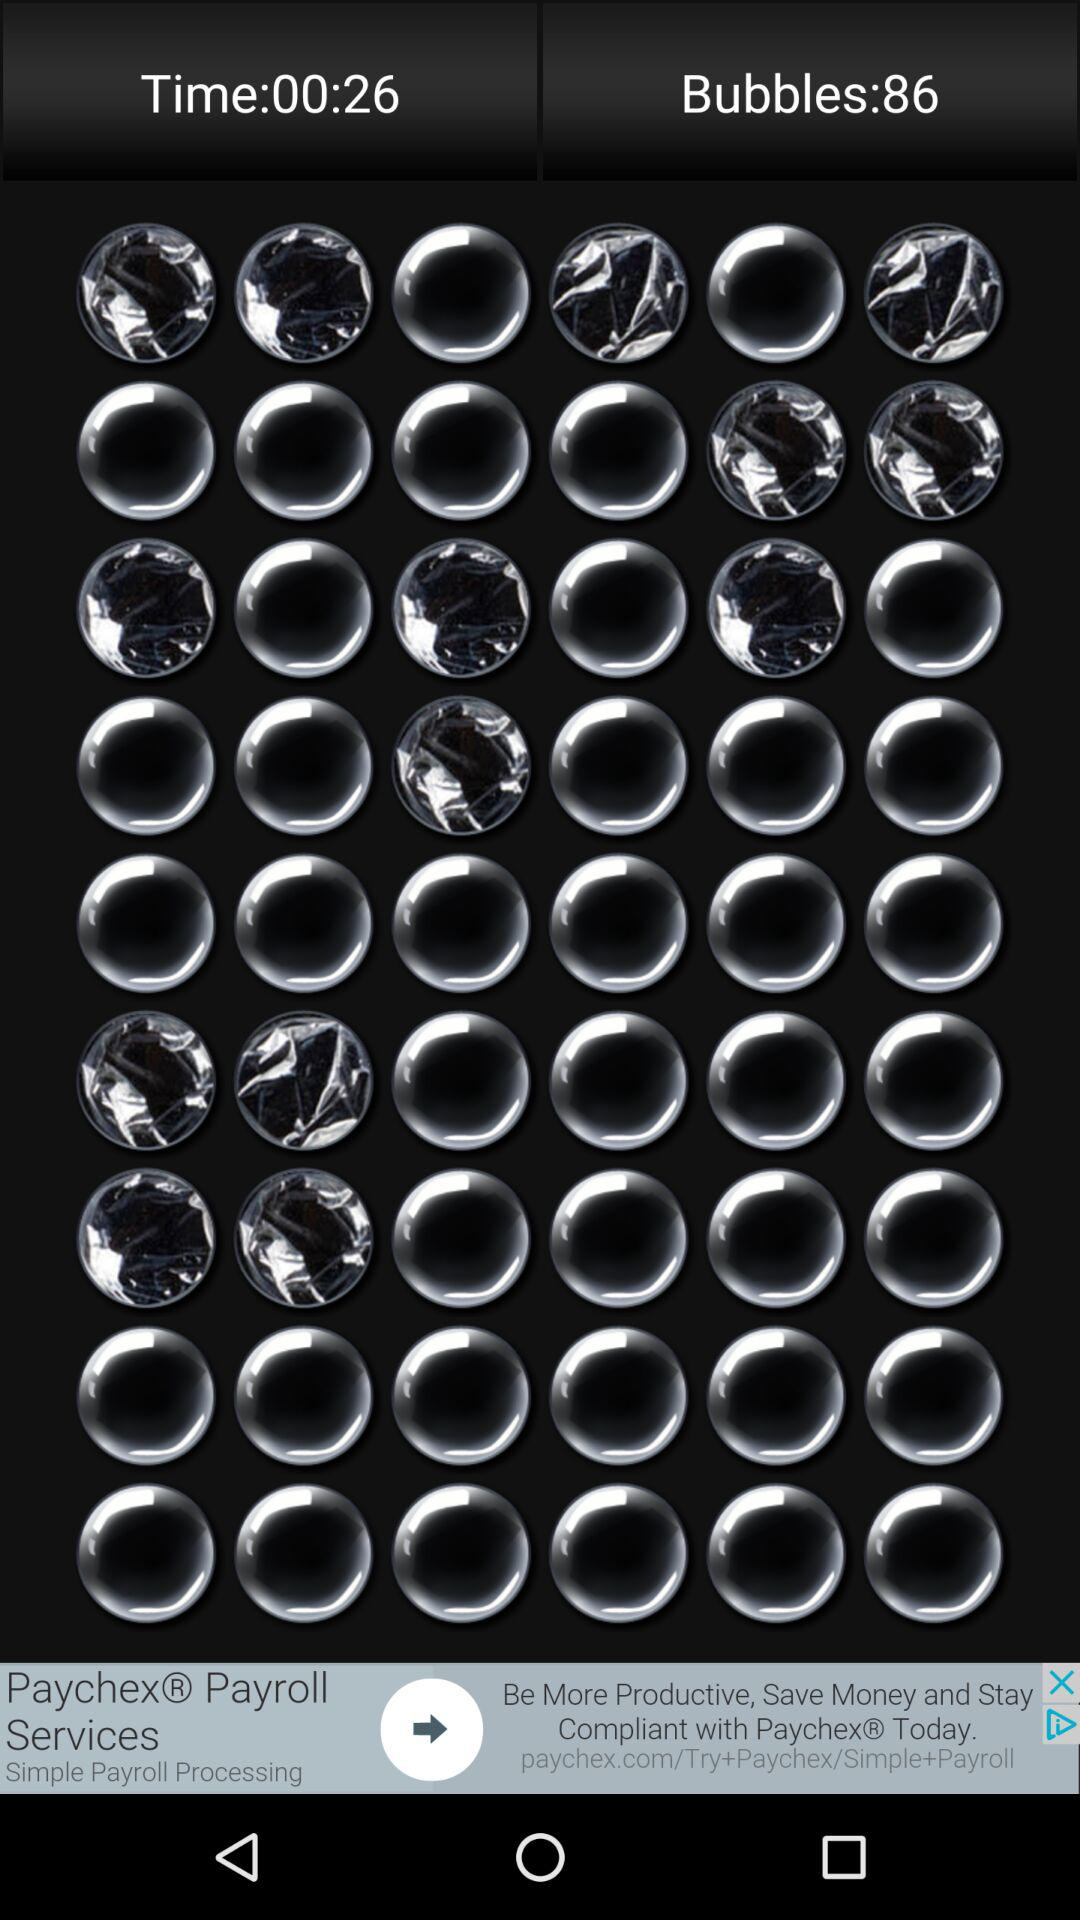What is the time? The time is 00:26. 